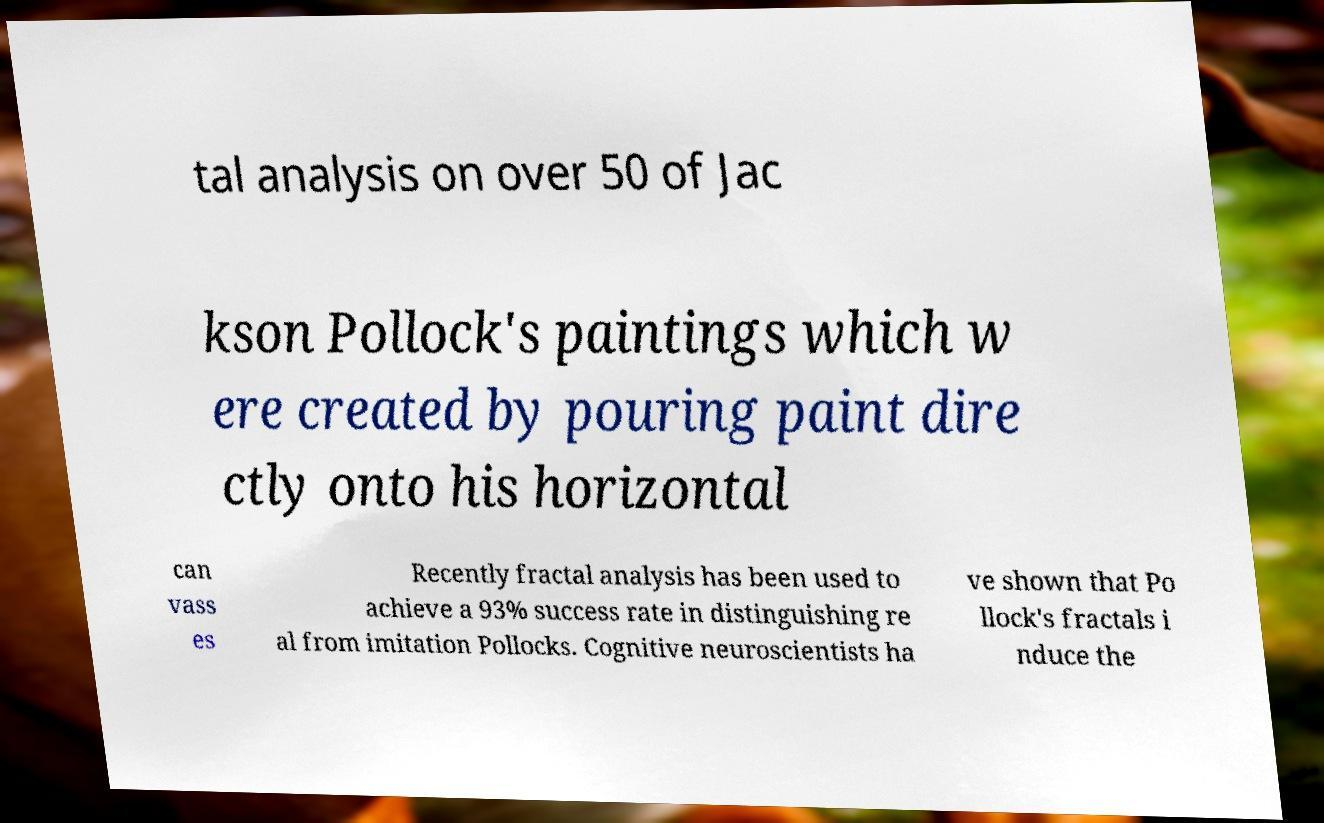Please read and relay the text visible in this image. What does it say? tal analysis on over 50 of Jac kson Pollock's paintings which w ere created by pouring paint dire ctly onto his horizontal can vass es Recently fractal analysis has been used to achieve a 93% success rate in distinguishing re al from imitation Pollocks. Cognitive neuroscientists ha ve shown that Po llock's fractals i nduce the 